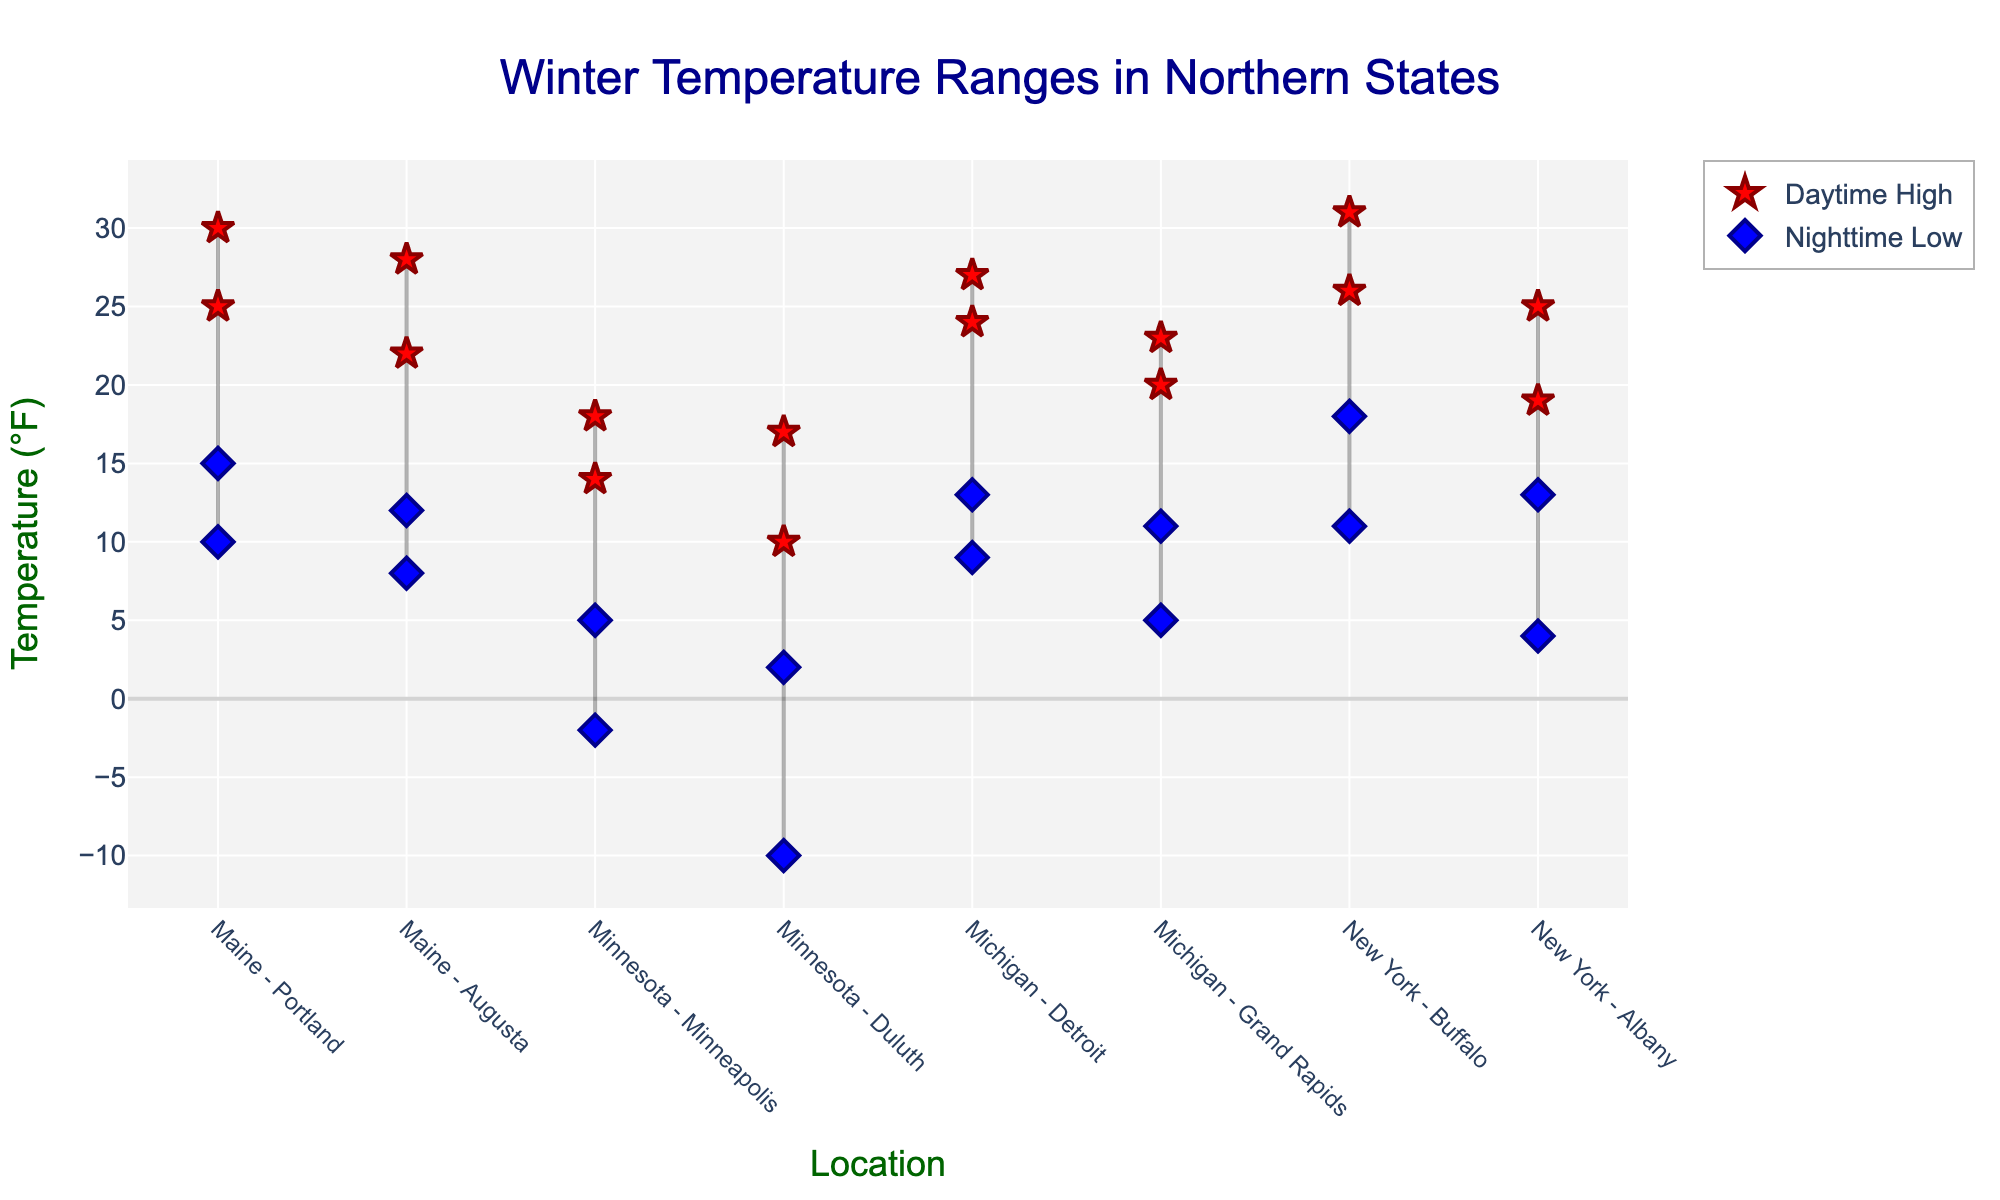Which city in Minnesota experienced the lowest nighttime temperature? Based on the vertical position of the blue diamonds, we identify that Duluth, Minnesota, had the lowest nighttime temperature, reaching -10°F.
Answer: Duluth What is the highest daytime temperature recorded across the states, and which city experienced it? By looking at the red stars, the highest daytime temperature is 31°F, recorded in Buffalo, New York.
Answer: Buffalo, 31°F Which state exhibited the widest range in temperature variation, and what was that range? To find this, subtract the lowest nighttime temperature from the highest daytime temperature in each state. For Minnesota: 18 - (-10) = 28. This is the widest range among all states.
Answer: Minnesota, 28°F How does the temperature range in Albany compare to that of Grand Rapids? Albany's temperature range is 19 (25°F - 6°F) and Grand Rapids' range is 18 (23°F - 5°F). Albany has a slightly wider range.
Answer: Albany is wider by 1°F How many locations in the plot have a daytime high temperature of exactly 25°F? By counting the red stars situated at 25°F on the y-axis, there are three cities: Portland (Maine), Albany (New York), and Augusta (Maine).
Answer: Three Which city shows the smallest difference between daytime high and nighttime low temperatures? Calculate differences for each city: smallest difference is 13 - 11 = 2°F in Grand Rapids, Michigan.
Answer: Grand Rapids On average, how much warmer are the daytime highs compared to the nighttime lows across all locations? Find the temperature differences for each location: 25-10, 30-15, 22-8, etc. Sum these up and divide by the number of locations (16 in total). The average difference is calculated as (15+15+14+16+16+13+20+15+15+14+15+12+15+18+15+12)/16 = 14.75°F.
Answer: 14.75°F Of the cities with the nighttime low temperatures below zero, which one recorded a daytime high temperature above 15°F? Identify cities with nighttime lows below 0°F: Duluth and Minneapolis, then check which of these had daytime highs above 15°F. Only Minneapolis recorded this (18°F).
Answer: Minneapolis 